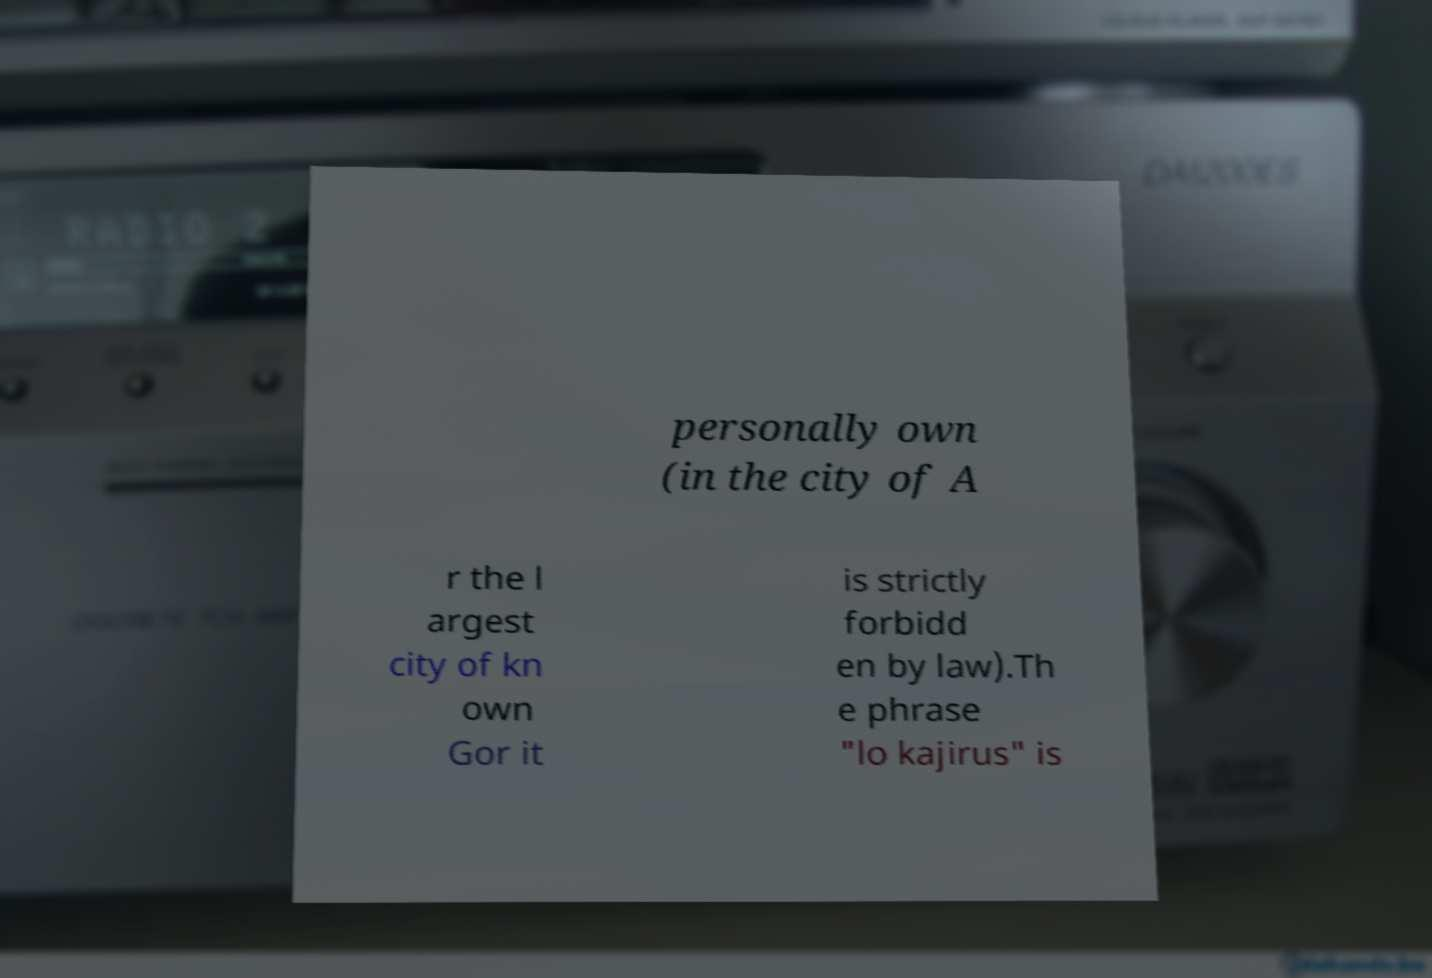Please read and relay the text visible in this image. What does it say? personally own (in the city of A r the l argest city of kn own Gor it is strictly forbidd en by law).Th e phrase "lo kajirus" is 